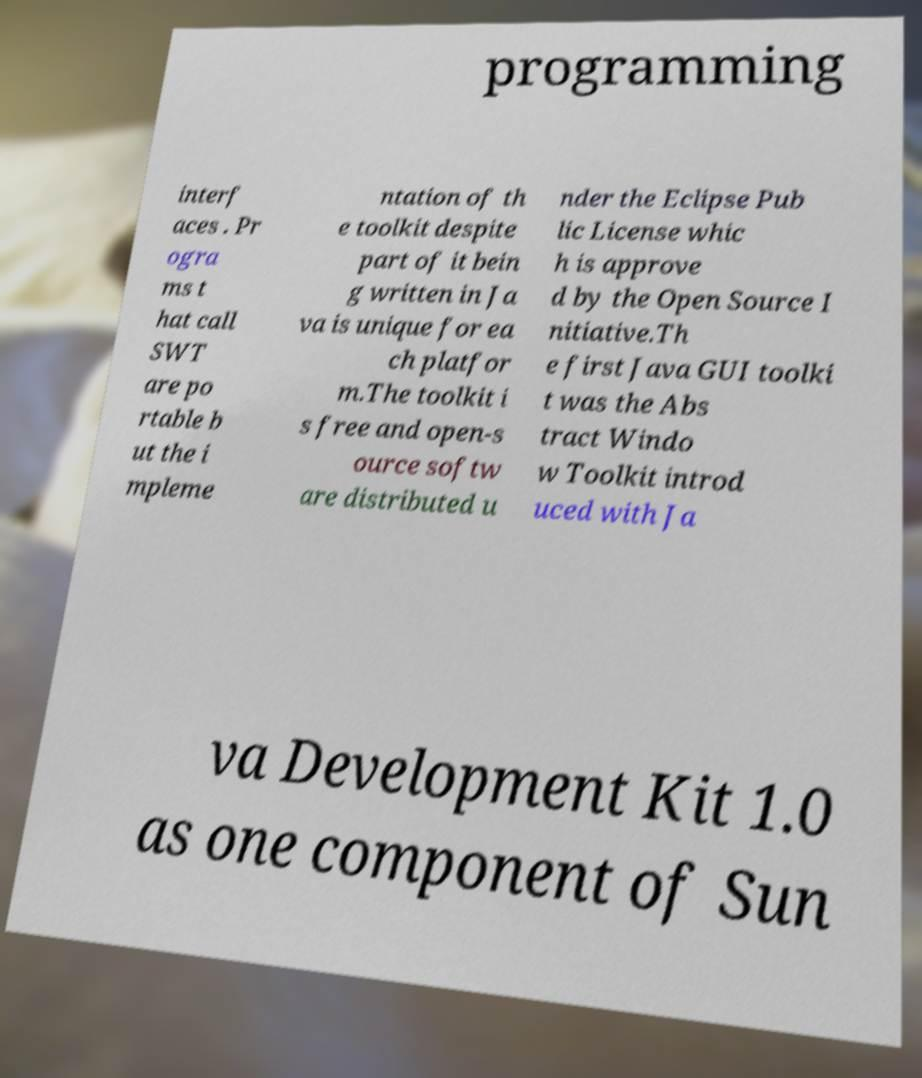For documentation purposes, I need the text within this image transcribed. Could you provide that? programming interf aces . Pr ogra ms t hat call SWT are po rtable b ut the i mpleme ntation of th e toolkit despite part of it bein g written in Ja va is unique for ea ch platfor m.The toolkit i s free and open-s ource softw are distributed u nder the Eclipse Pub lic License whic h is approve d by the Open Source I nitiative.Th e first Java GUI toolki t was the Abs tract Windo w Toolkit introd uced with Ja va Development Kit 1.0 as one component of Sun 